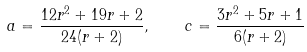Convert formula to latex. <formula><loc_0><loc_0><loc_500><loc_500>a = \frac { 1 2 r ^ { 2 } + 1 9 r + 2 } { 2 4 ( r + 2 ) } , \quad c = \frac { 3 r ^ { 2 } + 5 r + 1 } { 6 ( r + 2 ) }</formula> 